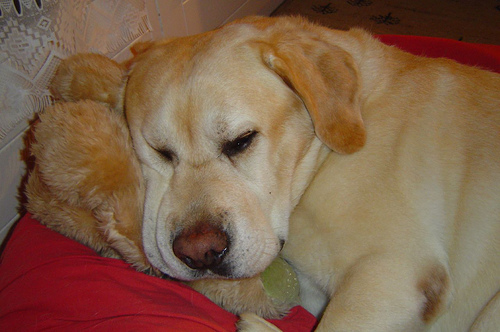How many dogs are there? There is one dog in the image, comfortably resting with its head on a red pillow and a tennis ball nearby, suggesting that it may enjoy playing fetch. 